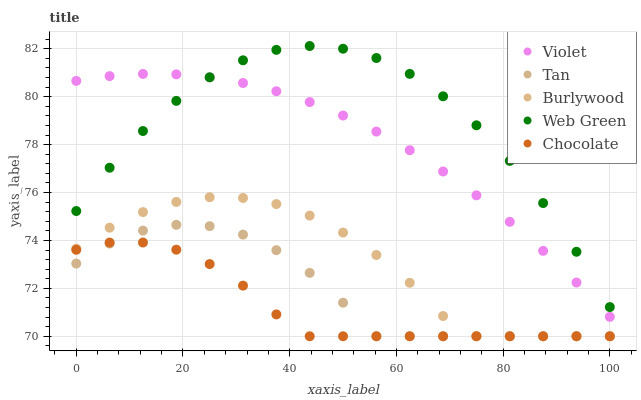Does Chocolate have the minimum area under the curve?
Answer yes or no. Yes. Does Web Green have the maximum area under the curve?
Answer yes or no. Yes. Does Tan have the minimum area under the curve?
Answer yes or no. No. Does Tan have the maximum area under the curve?
Answer yes or no. No. Is Violet the smoothest?
Answer yes or no. Yes. Is Web Green the roughest?
Answer yes or no. Yes. Is Tan the smoothest?
Answer yes or no. No. Is Tan the roughest?
Answer yes or no. No. Does Burlywood have the lowest value?
Answer yes or no. Yes. Does Web Green have the lowest value?
Answer yes or no. No. Does Web Green have the highest value?
Answer yes or no. Yes. Does Tan have the highest value?
Answer yes or no. No. Is Tan less than Web Green?
Answer yes or no. Yes. Is Web Green greater than Chocolate?
Answer yes or no. Yes. Does Chocolate intersect Tan?
Answer yes or no. Yes. Is Chocolate less than Tan?
Answer yes or no. No. Is Chocolate greater than Tan?
Answer yes or no. No. Does Tan intersect Web Green?
Answer yes or no. No. 